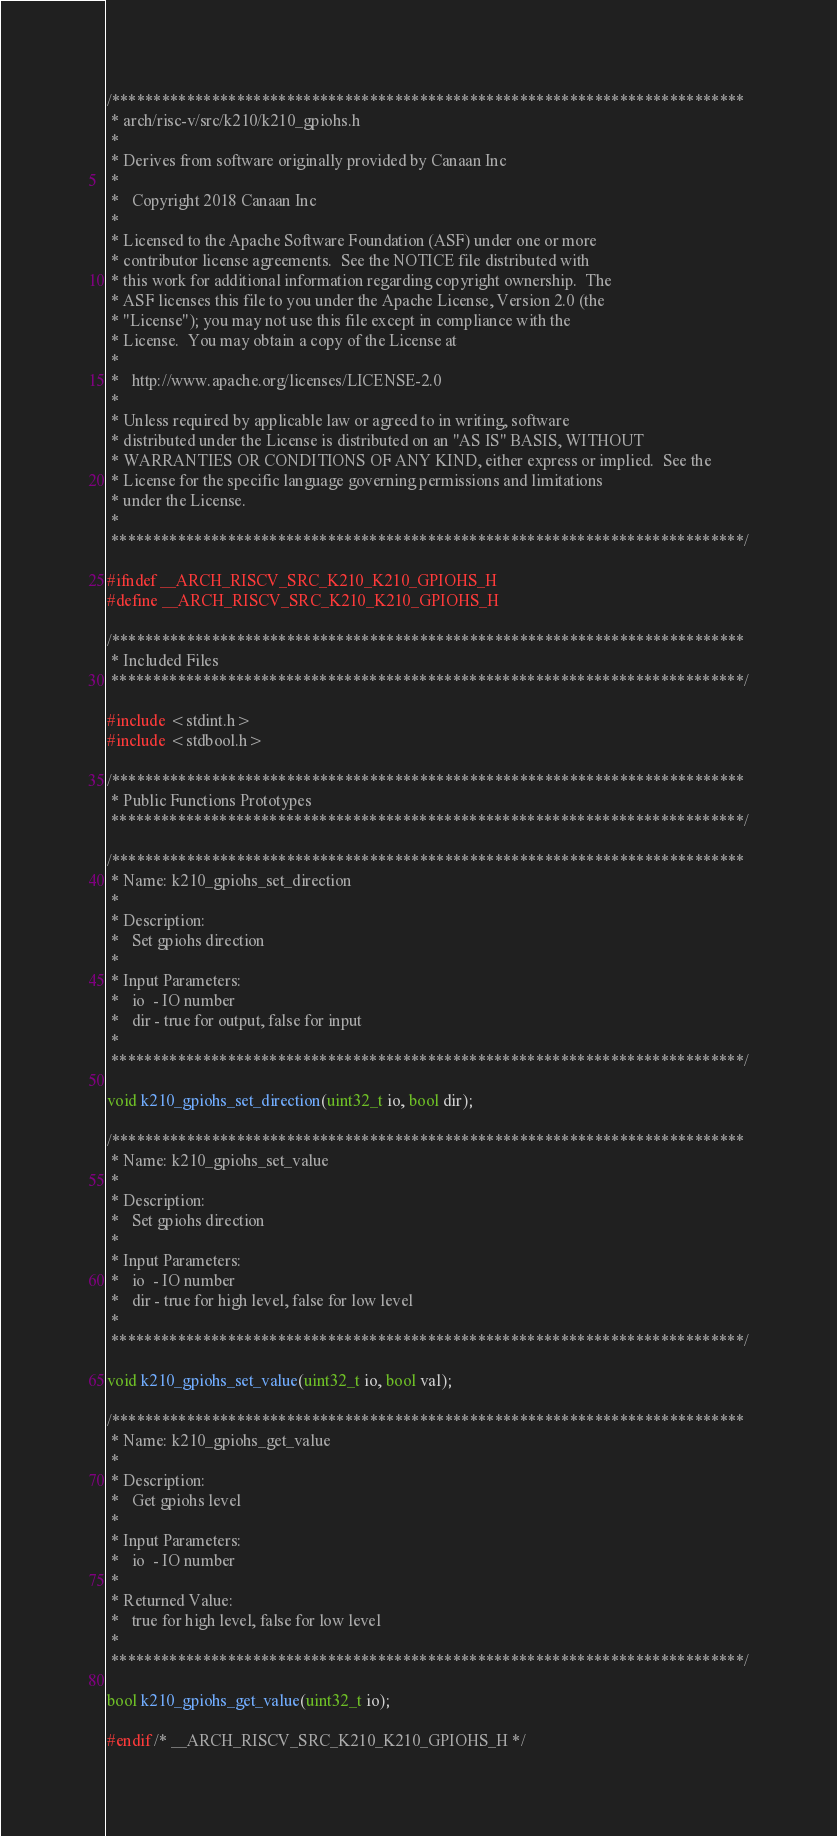Convert code to text. <code><loc_0><loc_0><loc_500><loc_500><_C_>/****************************************************************************
 * arch/risc-v/src/k210/k210_gpiohs.h
 *
 * Derives from software originally provided by Canaan Inc
 *
 *   Copyright 2018 Canaan Inc
 *
 * Licensed to the Apache Software Foundation (ASF) under one or more
 * contributor license agreements.  See the NOTICE file distributed with
 * this work for additional information regarding copyright ownership.  The
 * ASF licenses this file to you under the Apache License, Version 2.0 (the
 * "License"); you may not use this file except in compliance with the
 * License.  You may obtain a copy of the License at
 *
 *   http://www.apache.org/licenses/LICENSE-2.0
 *
 * Unless required by applicable law or agreed to in writing, software
 * distributed under the License is distributed on an "AS IS" BASIS, WITHOUT
 * WARRANTIES OR CONDITIONS OF ANY KIND, either express or implied.  See the
 * License for the specific language governing permissions and limitations
 * under the License.
 *
 ****************************************************************************/

#ifndef __ARCH_RISCV_SRC_K210_K210_GPIOHS_H
#define __ARCH_RISCV_SRC_K210_K210_GPIOHS_H

/****************************************************************************
 * Included Files
 ****************************************************************************/

#include <stdint.h>
#include <stdbool.h>

/****************************************************************************
 * Public Functions Prototypes
 ****************************************************************************/

/****************************************************************************
 * Name: k210_gpiohs_set_direction
 *
 * Description:
 *   Set gpiohs direction
 *
 * Input Parameters:
 *   io  - IO number
 *   dir - true for output, false for input
 *
 ****************************************************************************/

void k210_gpiohs_set_direction(uint32_t io, bool dir);

/****************************************************************************
 * Name: k210_gpiohs_set_value
 *
 * Description:
 *   Set gpiohs direction
 *
 * Input Parameters:
 *   io  - IO number
 *   dir - true for high level, false for low level
 *
 ****************************************************************************/

void k210_gpiohs_set_value(uint32_t io, bool val);

/****************************************************************************
 * Name: k210_gpiohs_get_value
 *
 * Description:
 *   Get gpiohs level
 *
 * Input Parameters:
 *   io  - IO number
 *
 * Returned Value:
 *   true for high level, false for low level
 *
 ****************************************************************************/

bool k210_gpiohs_get_value(uint32_t io);

#endif /* __ARCH_RISCV_SRC_K210_K210_GPIOHS_H */
</code> 